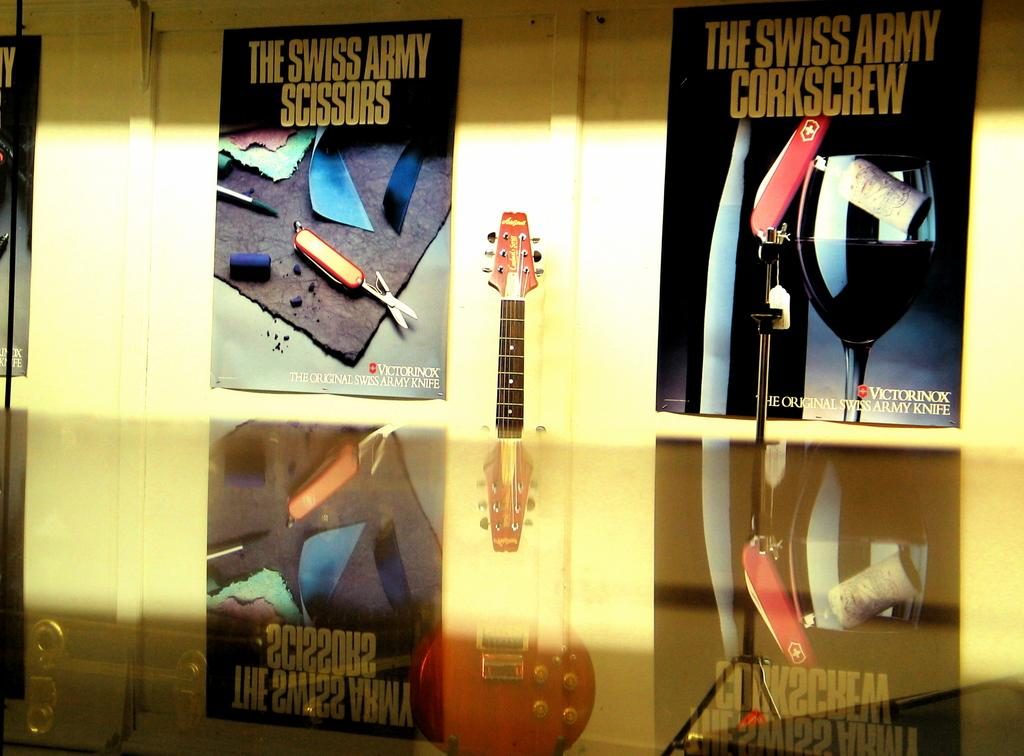<image>
Write a terse but informative summary of the picture. On either side of an electric guitar are two posters advertising Swiss Army knives. 